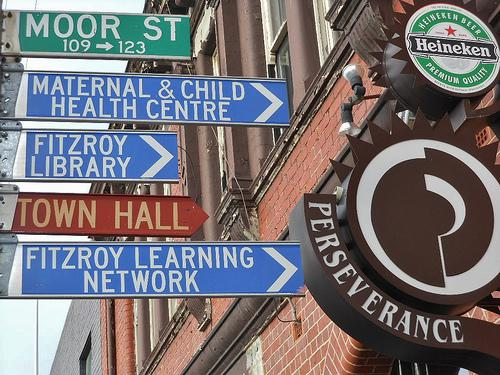Question: how many tab signs are there?
Choices:
A. 8.
B. 5.
C. 9.
D. 7.
Answer with the letter. Answer: B Question: how many red signs are there?
Choices:
A. 2.
B. 3.
C. 1.
D. 4.
Answer with the letter. Answer: C Question: what is the building made of?
Choices:
A. Glass.
B. Logs.
C. Brick.
D. Tin.
Answer with the letter. Answer: C Question: how many blue signs are shown?
Choices:
A. 4.
B. 3.
C. 5.
D. 6.
Answer with the letter. Answer: B Question: where is the street sign?
Choices:
A. On the pole.
B. Top of post.
C. In the ground.
D. Down the street.
Answer with the letter. Answer: B Question: how many round signs are shown?
Choices:
A. 2.
B. 3.
C. 4.
D. 5.
Answer with the letter. Answer: A 